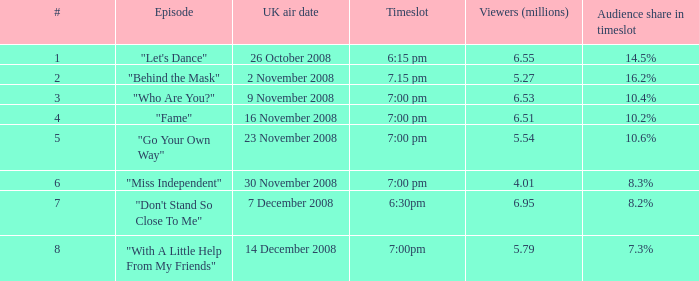Would you mind parsing the complete table? {'header': ['#', 'Episode', 'UK air date', 'Timeslot', 'Viewers (millions)', 'Audience share in timeslot'], 'rows': [['1', '"Let\'s Dance"', '26 October 2008', '6:15 pm', '6.55', '14.5%'], ['2', '"Behind the Mask"', '2 November 2008', '7.15 pm', '5.27', '16.2%'], ['3', '"Who Are You?"', '9 November 2008', '7:00 pm', '6.53', '10.4%'], ['4', '"Fame"', '16 November 2008', '7:00 pm', '6.51', '10.2%'], ['5', '"Go Your Own Way"', '23 November 2008', '7:00 pm', '5.54', '10.6%'], ['6', '"Miss Independent"', '30 November 2008', '7:00 pm', '4.01', '8.3%'], ['7', '"Don\'t Stand So Close To Me"', '7 December 2008', '6:30pm', '6.95', '8.2%'], ['8', '"With A Little Help From My Friends"', '14 December 2008', '7:00pm', '5.79', '7.3%']]} What is the total number of viewers corresponding to a 10.2% audience share in a specific timeslot? 1.0. 